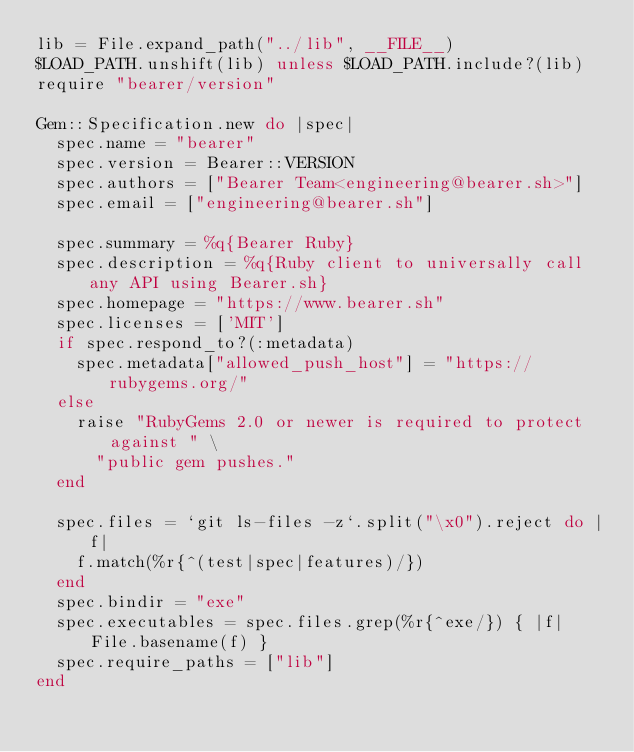<code> <loc_0><loc_0><loc_500><loc_500><_Ruby_>lib = File.expand_path("../lib", __FILE__)
$LOAD_PATH.unshift(lib) unless $LOAD_PATH.include?(lib)
require "bearer/version"

Gem::Specification.new do |spec|
  spec.name = "bearer"
  spec.version = Bearer::VERSION
  spec.authors = ["Bearer Team<engineering@bearer.sh>"]
  spec.email = ["engineering@bearer.sh"]

  spec.summary = %q{Bearer Ruby}
  spec.description = %q{Ruby client to universally call any API using Bearer.sh}
  spec.homepage = "https://www.bearer.sh"
  spec.licenses = ['MIT']
  if spec.respond_to?(:metadata)
    spec.metadata["allowed_push_host"] = "https://rubygems.org/"
  else
    raise "RubyGems 2.0 or newer is required to protect against " \
      "public gem pushes."
  end

  spec.files = `git ls-files -z`.split("\x0").reject do |f|
    f.match(%r{^(test|spec|features)/})
  end
  spec.bindir = "exe"
  spec.executables = spec.files.grep(%r{^exe/}) { |f| File.basename(f) }
  spec.require_paths = ["lib"]
end
</code> 